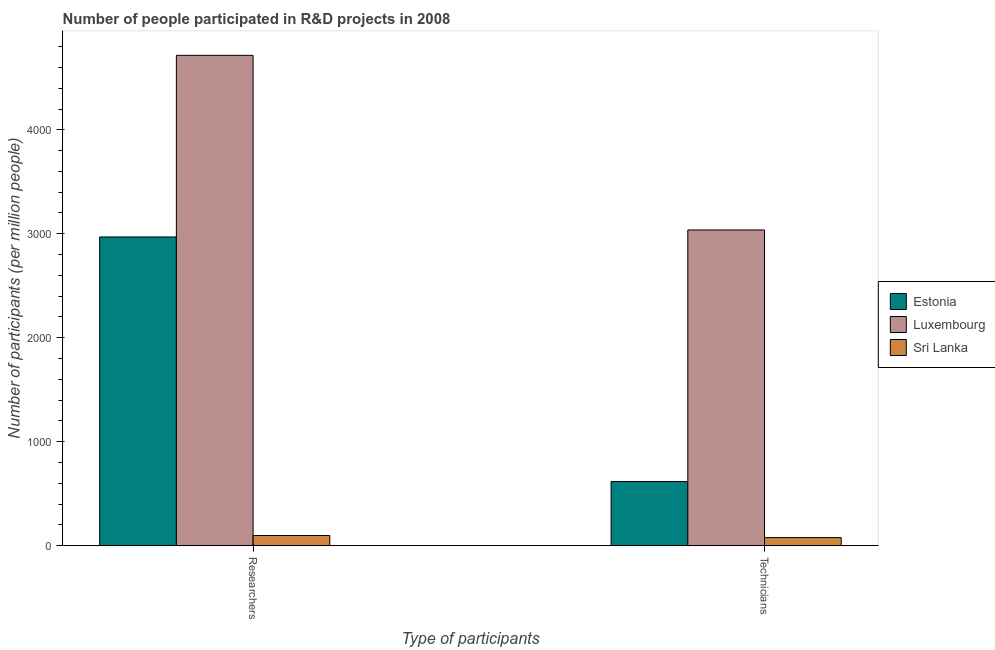Are the number of bars on each tick of the X-axis equal?
Ensure brevity in your answer.  Yes. How many bars are there on the 1st tick from the right?
Ensure brevity in your answer.  3. What is the label of the 1st group of bars from the left?
Your answer should be compact. Researchers. What is the number of technicians in Sri Lanka?
Keep it short and to the point. 78.75. Across all countries, what is the maximum number of researchers?
Give a very brief answer. 4715.93. Across all countries, what is the minimum number of technicians?
Offer a terse response. 78.75. In which country was the number of technicians maximum?
Your response must be concise. Luxembourg. In which country was the number of researchers minimum?
Provide a short and direct response. Sri Lanka. What is the total number of technicians in the graph?
Ensure brevity in your answer.  3733.51. What is the difference between the number of researchers in Sri Lanka and that in Luxembourg?
Give a very brief answer. -4617.08. What is the difference between the number of researchers in Sri Lanka and the number of technicians in Estonia?
Provide a short and direct response. -519.09. What is the average number of technicians per country?
Your answer should be compact. 1244.5. What is the difference between the number of researchers and number of technicians in Estonia?
Make the answer very short. 2351.6. In how many countries, is the number of technicians greater than 3000 ?
Give a very brief answer. 1. What is the ratio of the number of technicians in Luxembourg to that in Sri Lanka?
Give a very brief answer. 38.56. Is the number of researchers in Luxembourg less than that in Estonia?
Your response must be concise. No. In how many countries, is the number of researchers greater than the average number of researchers taken over all countries?
Ensure brevity in your answer.  2. What does the 2nd bar from the left in Technicians represents?
Your answer should be compact. Luxembourg. What does the 2nd bar from the right in Technicians represents?
Provide a succinct answer. Luxembourg. How many countries are there in the graph?
Make the answer very short. 3. What is the difference between two consecutive major ticks on the Y-axis?
Give a very brief answer. 1000. Are the values on the major ticks of Y-axis written in scientific E-notation?
Make the answer very short. No. Does the graph contain grids?
Offer a very short reply. No. What is the title of the graph?
Offer a very short reply. Number of people participated in R&D projects in 2008. What is the label or title of the X-axis?
Offer a very short reply. Type of participants. What is the label or title of the Y-axis?
Ensure brevity in your answer.  Number of participants (per million people). What is the Number of participants (per million people) of Estonia in Researchers?
Give a very brief answer. 2969.53. What is the Number of participants (per million people) of Luxembourg in Researchers?
Your response must be concise. 4715.93. What is the Number of participants (per million people) in Sri Lanka in Researchers?
Offer a terse response. 98.85. What is the Number of participants (per million people) of Estonia in Technicians?
Your answer should be compact. 617.94. What is the Number of participants (per million people) in Luxembourg in Technicians?
Make the answer very short. 3036.82. What is the Number of participants (per million people) in Sri Lanka in Technicians?
Your response must be concise. 78.75. Across all Type of participants, what is the maximum Number of participants (per million people) of Estonia?
Make the answer very short. 2969.53. Across all Type of participants, what is the maximum Number of participants (per million people) of Luxembourg?
Provide a succinct answer. 4715.93. Across all Type of participants, what is the maximum Number of participants (per million people) in Sri Lanka?
Keep it short and to the point. 98.85. Across all Type of participants, what is the minimum Number of participants (per million people) of Estonia?
Your response must be concise. 617.94. Across all Type of participants, what is the minimum Number of participants (per million people) in Luxembourg?
Keep it short and to the point. 3036.82. Across all Type of participants, what is the minimum Number of participants (per million people) in Sri Lanka?
Ensure brevity in your answer.  78.75. What is the total Number of participants (per million people) of Estonia in the graph?
Offer a very short reply. 3587.47. What is the total Number of participants (per million people) in Luxembourg in the graph?
Provide a succinct answer. 7752.76. What is the total Number of participants (per million people) in Sri Lanka in the graph?
Provide a succinct answer. 177.6. What is the difference between the Number of participants (per million people) in Estonia in Researchers and that in Technicians?
Offer a terse response. 2351.6. What is the difference between the Number of participants (per million people) of Luxembourg in Researchers and that in Technicians?
Provide a succinct answer. 1679.11. What is the difference between the Number of participants (per million people) of Sri Lanka in Researchers and that in Technicians?
Provide a succinct answer. 20.1. What is the difference between the Number of participants (per million people) in Estonia in Researchers and the Number of participants (per million people) in Luxembourg in Technicians?
Provide a succinct answer. -67.29. What is the difference between the Number of participants (per million people) of Estonia in Researchers and the Number of participants (per million people) of Sri Lanka in Technicians?
Keep it short and to the point. 2890.79. What is the difference between the Number of participants (per million people) of Luxembourg in Researchers and the Number of participants (per million people) of Sri Lanka in Technicians?
Ensure brevity in your answer.  4637.18. What is the average Number of participants (per million people) in Estonia per Type of participants?
Give a very brief answer. 1793.74. What is the average Number of participants (per million people) of Luxembourg per Type of participants?
Your response must be concise. 3876.38. What is the average Number of participants (per million people) in Sri Lanka per Type of participants?
Your response must be concise. 88.8. What is the difference between the Number of participants (per million people) in Estonia and Number of participants (per million people) in Luxembourg in Researchers?
Your answer should be very brief. -1746.4. What is the difference between the Number of participants (per million people) in Estonia and Number of participants (per million people) in Sri Lanka in Researchers?
Offer a terse response. 2870.68. What is the difference between the Number of participants (per million people) in Luxembourg and Number of participants (per million people) in Sri Lanka in Researchers?
Provide a succinct answer. 4617.08. What is the difference between the Number of participants (per million people) in Estonia and Number of participants (per million people) in Luxembourg in Technicians?
Your answer should be compact. -2418.89. What is the difference between the Number of participants (per million people) in Estonia and Number of participants (per million people) in Sri Lanka in Technicians?
Offer a very short reply. 539.19. What is the difference between the Number of participants (per million people) of Luxembourg and Number of participants (per million people) of Sri Lanka in Technicians?
Your answer should be very brief. 2958.08. What is the ratio of the Number of participants (per million people) in Estonia in Researchers to that in Technicians?
Your response must be concise. 4.81. What is the ratio of the Number of participants (per million people) in Luxembourg in Researchers to that in Technicians?
Ensure brevity in your answer.  1.55. What is the ratio of the Number of participants (per million people) of Sri Lanka in Researchers to that in Technicians?
Your answer should be very brief. 1.26. What is the difference between the highest and the second highest Number of participants (per million people) in Estonia?
Give a very brief answer. 2351.6. What is the difference between the highest and the second highest Number of participants (per million people) of Luxembourg?
Offer a very short reply. 1679.11. What is the difference between the highest and the second highest Number of participants (per million people) in Sri Lanka?
Offer a terse response. 20.1. What is the difference between the highest and the lowest Number of participants (per million people) in Estonia?
Your response must be concise. 2351.6. What is the difference between the highest and the lowest Number of participants (per million people) of Luxembourg?
Your answer should be very brief. 1679.11. What is the difference between the highest and the lowest Number of participants (per million people) of Sri Lanka?
Keep it short and to the point. 20.1. 